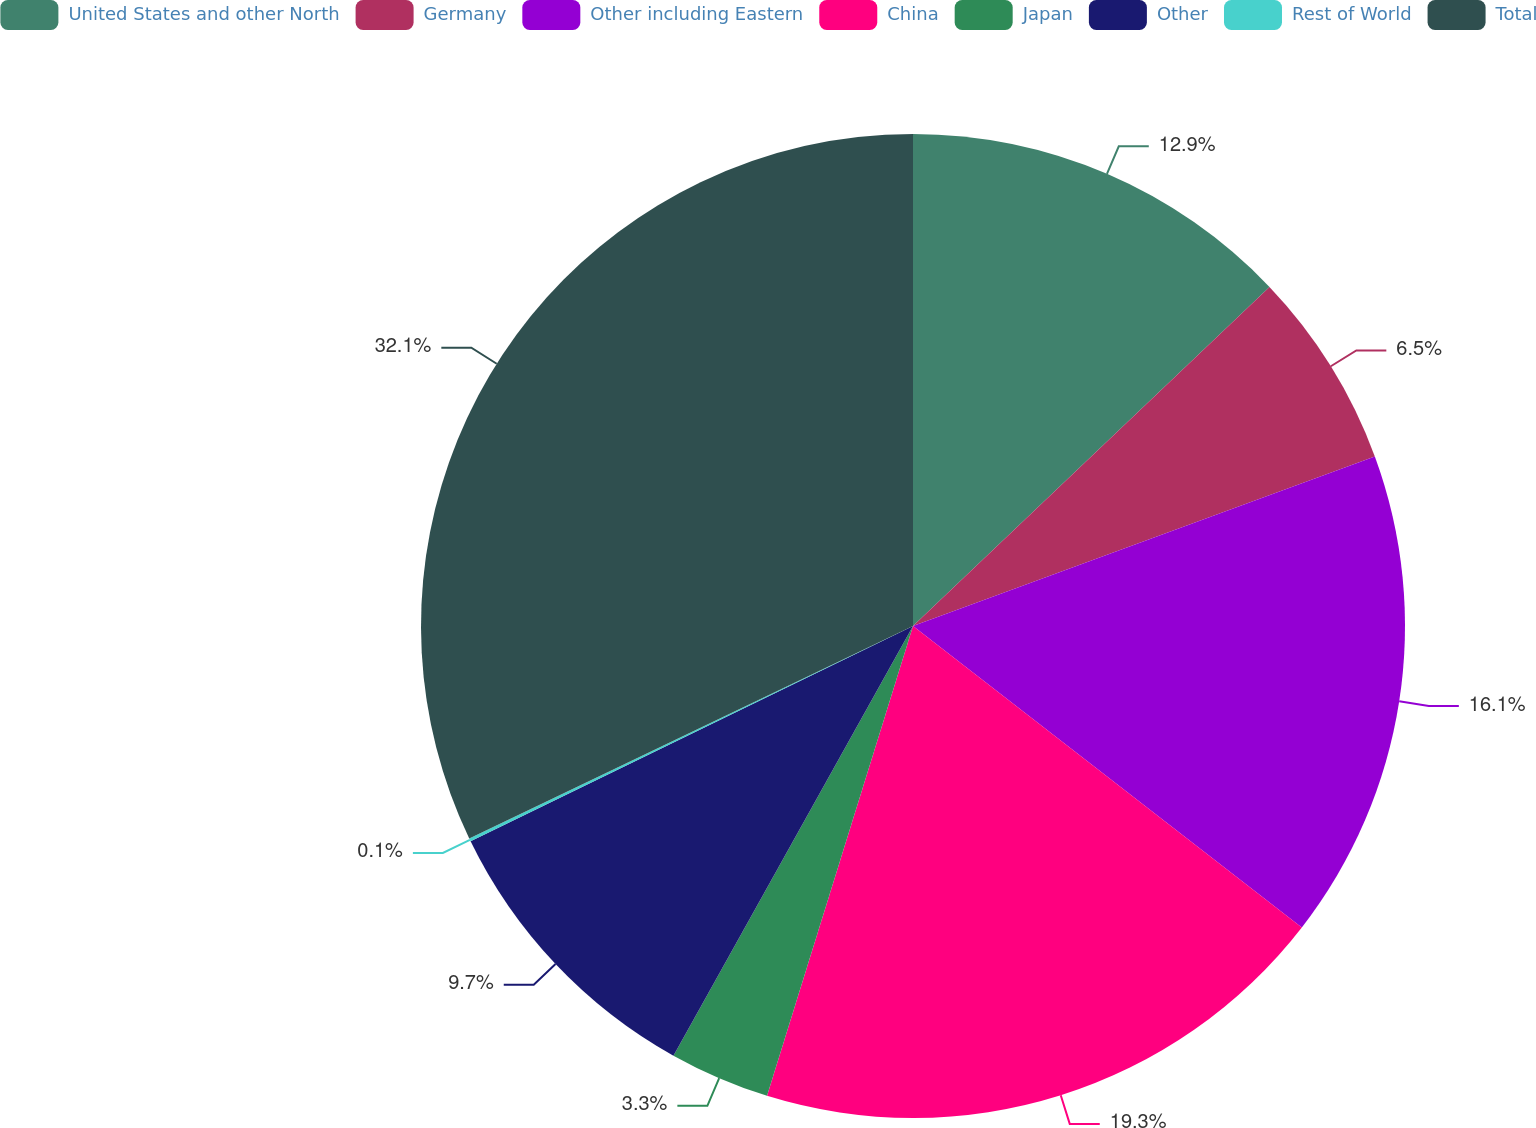Convert chart. <chart><loc_0><loc_0><loc_500><loc_500><pie_chart><fcel>United States and other North<fcel>Germany<fcel>Other including Eastern<fcel>China<fcel>Japan<fcel>Other<fcel>Rest of World<fcel>Total<nl><fcel>12.9%<fcel>6.5%<fcel>16.1%<fcel>19.3%<fcel>3.3%<fcel>9.7%<fcel>0.1%<fcel>32.11%<nl></chart> 